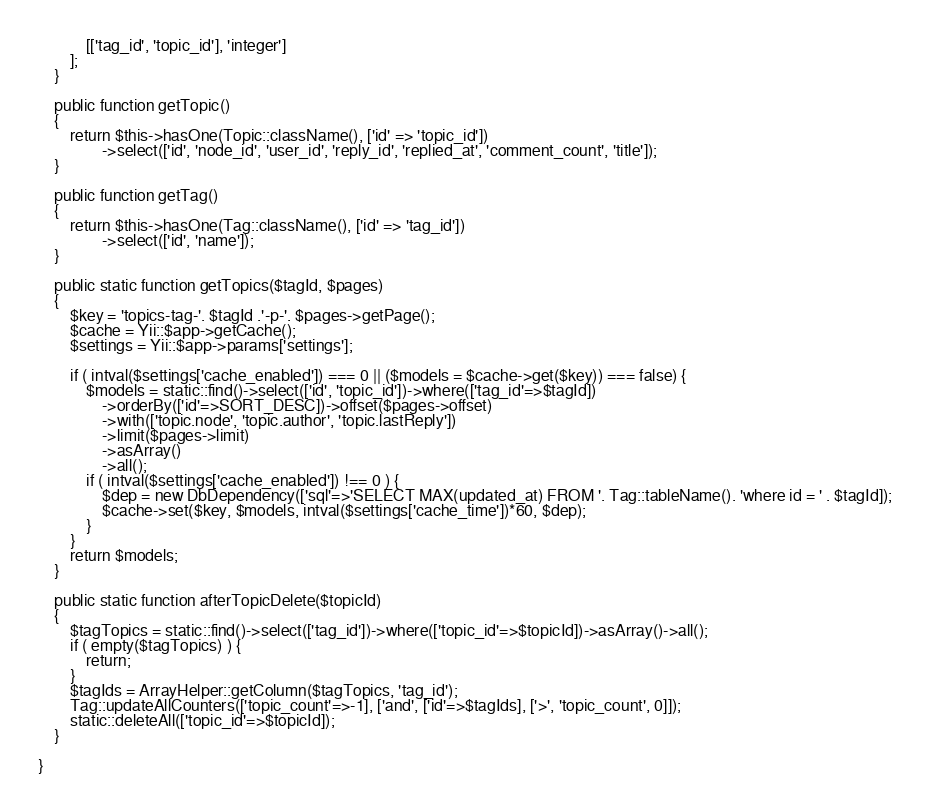Convert code to text. <code><loc_0><loc_0><loc_500><loc_500><_PHP_>            [['tag_id', 'topic_id'], 'integer']
        ];
    }

	public function getTopic()
    {
        return $this->hasOne(Topic::className(), ['id' => 'topic_id'])
				->select(['id', 'node_id', 'user_id', 'reply_id', 'replied_at', 'comment_count', 'title']);
    }

	public function getTag()
    {
        return $this->hasOne(Tag::className(), ['id' => 'tag_id'])
				->select(['id', 'name']);
    }

	public static function getTopics($tagId, $pages)
	{
		$key = 'topics-tag-'. $tagId .'-p-'. $pages->getPage();
		$cache = Yii::$app->getCache();
		$settings = Yii::$app->params['settings'];

		if ( intval($settings['cache_enabled']) === 0 || ($models = $cache->get($key)) === false) {
		    $models = static::find()->select(['id', 'topic_id'])->where(['tag_id'=>$tagId])
				->orderBy(['id'=>SORT_DESC])->offset($pages->offset)
				->with(['topic.node', 'topic.author', 'topic.lastReply'])
		        ->limit($pages->limit)
				->asArray()
		        ->all();
			if ( intval($settings['cache_enabled']) !== 0 ) {
				$dep = new DbDependency(['sql'=>'SELECT MAX(updated_at) FROM '. Tag::tableName(). 'where id = ' . $tagId]);
				$cache->set($key, $models, intval($settings['cache_time'])*60, $dep);
			}
		}
		return $models;
	}

	public static function afterTopicDelete($topicId)
	{
		$tagTopics = static::find()->select(['tag_id'])->where(['topic_id'=>$topicId])->asArray()->all();
		if ( empty($tagTopics) ) {
			return;
		}
		$tagIds = ArrayHelper::getColumn($tagTopics, 'tag_id');
		Tag::updateAllCounters(['topic_count'=>-1], ['and', ['id'=>$tagIds], ['>', 'topic_count', 0]]);
		static::deleteAll(['topic_id'=>$topicId]);
	}

}
</code> 